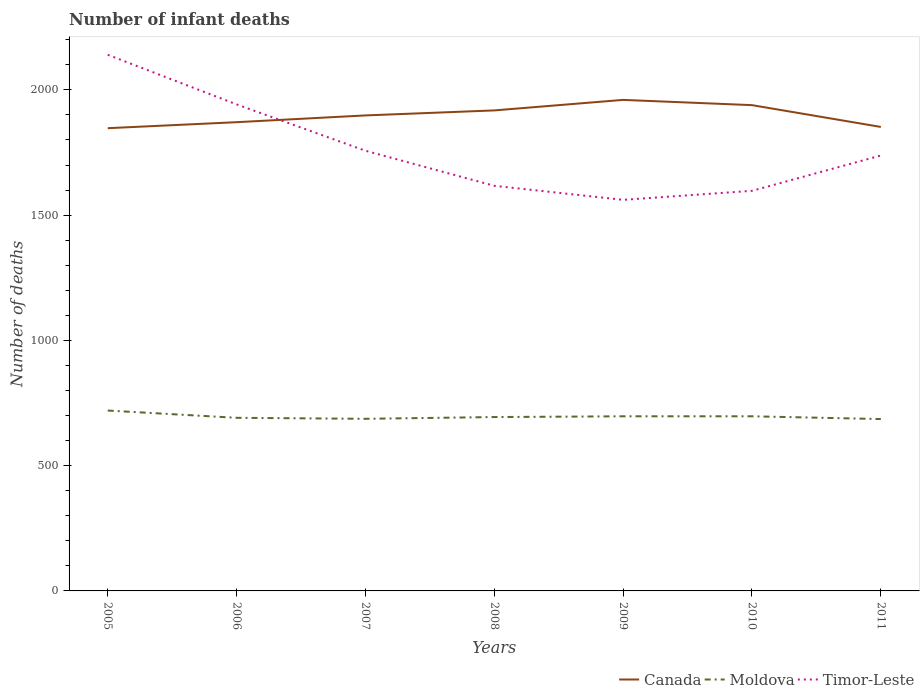Does the line corresponding to Canada intersect with the line corresponding to Moldova?
Provide a succinct answer. No. Across all years, what is the maximum number of infant deaths in Moldova?
Ensure brevity in your answer.  686. In which year was the number of infant deaths in Timor-Leste maximum?
Provide a succinct answer. 2009. What is the total number of infant deaths in Canada in the graph?
Offer a terse response. 87. What is the difference between the highest and the lowest number of infant deaths in Moldova?
Make the answer very short. 3. Is the number of infant deaths in Canada strictly greater than the number of infant deaths in Timor-Leste over the years?
Keep it short and to the point. No. How many lines are there?
Provide a succinct answer. 3. How many years are there in the graph?
Offer a very short reply. 7. Does the graph contain any zero values?
Provide a succinct answer. No. Does the graph contain grids?
Your answer should be very brief. No. What is the title of the graph?
Ensure brevity in your answer.  Number of infant deaths. Does "Senegal" appear as one of the legend labels in the graph?
Your response must be concise. No. What is the label or title of the X-axis?
Make the answer very short. Years. What is the label or title of the Y-axis?
Offer a very short reply. Number of deaths. What is the Number of deaths in Canada in 2005?
Provide a short and direct response. 1847. What is the Number of deaths of Moldova in 2005?
Ensure brevity in your answer.  720. What is the Number of deaths of Timor-Leste in 2005?
Keep it short and to the point. 2140. What is the Number of deaths of Canada in 2006?
Your answer should be very brief. 1871. What is the Number of deaths in Moldova in 2006?
Provide a short and direct response. 691. What is the Number of deaths in Timor-Leste in 2006?
Give a very brief answer. 1942. What is the Number of deaths in Canada in 2007?
Keep it short and to the point. 1898. What is the Number of deaths of Moldova in 2007?
Make the answer very short. 687. What is the Number of deaths of Timor-Leste in 2007?
Ensure brevity in your answer.  1757. What is the Number of deaths in Canada in 2008?
Ensure brevity in your answer.  1918. What is the Number of deaths in Moldova in 2008?
Provide a short and direct response. 694. What is the Number of deaths of Timor-Leste in 2008?
Offer a very short reply. 1617. What is the Number of deaths in Canada in 2009?
Keep it short and to the point. 1960. What is the Number of deaths in Moldova in 2009?
Your response must be concise. 697. What is the Number of deaths in Timor-Leste in 2009?
Give a very brief answer. 1561. What is the Number of deaths of Canada in 2010?
Make the answer very short. 1939. What is the Number of deaths in Moldova in 2010?
Make the answer very short. 697. What is the Number of deaths in Timor-Leste in 2010?
Keep it short and to the point. 1597. What is the Number of deaths in Canada in 2011?
Your answer should be very brief. 1852. What is the Number of deaths in Moldova in 2011?
Provide a short and direct response. 686. What is the Number of deaths of Timor-Leste in 2011?
Give a very brief answer. 1738. Across all years, what is the maximum Number of deaths of Canada?
Provide a succinct answer. 1960. Across all years, what is the maximum Number of deaths of Moldova?
Your response must be concise. 720. Across all years, what is the maximum Number of deaths in Timor-Leste?
Offer a terse response. 2140. Across all years, what is the minimum Number of deaths of Canada?
Your response must be concise. 1847. Across all years, what is the minimum Number of deaths in Moldova?
Keep it short and to the point. 686. Across all years, what is the minimum Number of deaths of Timor-Leste?
Offer a very short reply. 1561. What is the total Number of deaths in Canada in the graph?
Provide a succinct answer. 1.33e+04. What is the total Number of deaths of Moldova in the graph?
Give a very brief answer. 4872. What is the total Number of deaths in Timor-Leste in the graph?
Provide a succinct answer. 1.24e+04. What is the difference between the Number of deaths of Canada in 2005 and that in 2006?
Your answer should be very brief. -24. What is the difference between the Number of deaths in Moldova in 2005 and that in 2006?
Your response must be concise. 29. What is the difference between the Number of deaths in Timor-Leste in 2005 and that in 2006?
Offer a very short reply. 198. What is the difference between the Number of deaths of Canada in 2005 and that in 2007?
Offer a terse response. -51. What is the difference between the Number of deaths in Moldova in 2005 and that in 2007?
Make the answer very short. 33. What is the difference between the Number of deaths of Timor-Leste in 2005 and that in 2007?
Your response must be concise. 383. What is the difference between the Number of deaths of Canada in 2005 and that in 2008?
Keep it short and to the point. -71. What is the difference between the Number of deaths of Timor-Leste in 2005 and that in 2008?
Ensure brevity in your answer.  523. What is the difference between the Number of deaths in Canada in 2005 and that in 2009?
Provide a succinct answer. -113. What is the difference between the Number of deaths of Moldova in 2005 and that in 2009?
Offer a very short reply. 23. What is the difference between the Number of deaths in Timor-Leste in 2005 and that in 2009?
Keep it short and to the point. 579. What is the difference between the Number of deaths of Canada in 2005 and that in 2010?
Offer a terse response. -92. What is the difference between the Number of deaths of Moldova in 2005 and that in 2010?
Your answer should be very brief. 23. What is the difference between the Number of deaths of Timor-Leste in 2005 and that in 2010?
Ensure brevity in your answer.  543. What is the difference between the Number of deaths in Canada in 2005 and that in 2011?
Make the answer very short. -5. What is the difference between the Number of deaths of Timor-Leste in 2005 and that in 2011?
Offer a very short reply. 402. What is the difference between the Number of deaths of Moldova in 2006 and that in 2007?
Your answer should be very brief. 4. What is the difference between the Number of deaths in Timor-Leste in 2006 and that in 2007?
Give a very brief answer. 185. What is the difference between the Number of deaths of Canada in 2006 and that in 2008?
Offer a very short reply. -47. What is the difference between the Number of deaths of Timor-Leste in 2006 and that in 2008?
Give a very brief answer. 325. What is the difference between the Number of deaths in Canada in 2006 and that in 2009?
Your response must be concise. -89. What is the difference between the Number of deaths of Moldova in 2006 and that in 2009?
Your answer should be compact. -6. What is the difference between the Number of deaths of Timor-Leste in 2006 and that in 2009?
Your answer should be compact. 381. What is the difference between the Number of deaths of Canada in 2006 and that in 2010?
Make the answer very short. -68. What is the difference between the Number of deaths in Timor-Leste in 2006 and that in 2010?
Give a very brief answer. 345. What is the difference between the Number of deaths in Moldova in 2006 and that in 2011?
Make the answer very short. 5. What is the difference between the Number of deaths of Timor-Leste in 2006 and that in 2011?
Make the answer very short. 204. What is the difference between the Number of deaths in Moldova in 2007 and that in 2008?
Provide a succinct answer. -7. What is the difference between the Number of deaths of Timor-Leste in 2007 and that in 2008?
Ensure brevity in your answer.  140. What is the difference between the Number of deaths of Canada in 2007 and that in 2009?
Offer a terse response. -62. What is the difference between the Number of deaths in Timor-Leste in 2007 and that in 2009?
Your response must be concise. 196. What is the difference between the Number of deaths of Canada in 2007 and that in 2010?
Offer a terse response. -41. What is the difference between the Number of deaths of Moldova in 2007 and that in 2010?
Keep it short and to the point. -10. What is the difference between the Number of deaths in Timor-Leste in 2007 and that in 2010?
Your response must be concise. 160. What is the difference between the Number of deaths in Canada in 2007 and that in 2011?
Your response must be concise. 46. What is the difference between the Number of deaths of Moldova in 2007 and that in 2011?
Keep it short and to the point. 1. What is the difference between the Number of deaths of Canada in 2008 and that in 2009?
Your answer should be very brief. -42. What is the difference between the Number of deaths of Moldova in 2008 and that in 2009?
Offer a terse response. -3. What is the difference between the Number of deaths of Canada in 2008 and that in 2010?
Provide a short and direct response. -21. What is the difference between the Number of deaths of Moldova in 2008 and that in 2010?
Provide a short and direct response. -3. What is the difference between the Number of deaths in Canada in 2008 and that in 2011?
Make the answer very short. 66. What is the difference between the Number of deaths of Timor-Leste in 2008 and that in 2011?
Ensure brevity in your answer.  -121. What is the difference between the Number of deaths in Moldova in 2009 and that in 2010?
Give a very brief answer. 0. What is the difference between the Number of deaths in Timor-Leste in 2009 and that in 2010?
Keep it short and to the point. -36. What is the difference between the Number of deaths in Canada in 2009 and that in 2011?
Offer a terse response. 108. What is the difference between the Number of deaths of Moldova in 2009 and that in 2011?
Provide a succinct answer. 11. What is the difference between the Number of deaths of Timor-Leste in 2009 and that in 2011?
Provide a short and direct response. -177. What is the difference between the Number of deaths in Moldova in 2010 and that in 2011?
Your answer should be compact. 11. What is the difference between the Number of deaths in Timor-Leste in 2010 and that in 2011?
Ensure brevity in your answer.  -141. What is the difference between the Number of deaths of Canada in 2005 and the Number of deaths of Moldova in 2006?
Provide a succinct answer. 1156. What is the difference between the Number of deaths of Canada in 2005 and the Number of deaths of Timor-Leste in 2006?
Offer a terse response. -95. What is the difference between the Number of deaths in Moldova in 2005 and the Number of deaths in Timor-Leste in 2006?
Your response must be concise. -1222. What is the difference between the Number of deaths in Canada in 2005 and the Number of deaths in Moldova in 2007?
Make the answer very short. 1160. What is the difference between the Number of deaths in Canada in 2005 and the Number of deaths in Timor-Leste in 2007?
Your response must be concise. 90. What is the difference between the Number of deaths in Moldova in 2005 and the Number of deaths in Timor-Leste in 2007?
Ensure brevity in your answer.  -1037. What is the difference between the Number of deaths of Canada in 2005 and the Number of deaths of Moldova in 2008?
Provide a succinct answer. 1153. What is the difference between the Number of deaths of Canada in 2005 and the Number of deaths of Timor-Leste in 2008?
Provide a short and direct response. 230. What is the difference between the Number of deaths in Moldova in 2005 and the Number of deaths in Timor-Leste in 2008?
Provide a short and direct response. -897. What is the difference between the Number of deaths in Canada in 2005 and the Number of deaths in Moldova in 2009?
Your answer should be compact. 1150. What is the difference between the Number of deaths in Canada in 2005 and the Number of deaths in Timor-Leste in 2009?
Make the answer very short. 286. What is the difference between the Number of deaths in Moldova in 2005 and the Number of deaths in Timor-Leste in 2009?
Your response must be concise. -841. What is the difference between the Number of deaths of Canada in 2005 and the Number of deaths of Moldova in 2010?
Make the answer very short. 1150. What is the difference between the Number of deaths in Canada in 2005 and the Number of deaths in Timor-Leste in 2010?
Provide a succinct answer. 250. What is the difference between the Number of deaths in Moldova in 2005 and the Number of deaths in Timor-Leste in 2010?
Provide a short and direct response. -877. What is the difference between the Number of deaths of Canada in 2005 and the Number of deaths of Moldova in 2011?
Provide a short and direct response. 1161. What is the difference between the Number of deaths in Canada in 2005 and the Number of deaths in Timor-Leste in 2011?
Offer a terse response. 109. What is the difference between the Number of deaths in Moldova in 2005 and the Number of deaths in Timor-Leste in 2011?
Offer a terse response. -1018. What is the difference between the Number of deaths in Canada in 2006 and the Number of deaths in Moldova in 2007?
Keep it short and to the point. 1184. What is the difference between the Number of deaths in Canada in 2006 and the Number of deaths in Timor-Leste in 2007?
Provide a succinct answer. 114. What is the difference between the Number of deaths of Moldova in 2006 and the Number of deaths of Timor-Leste in 2007?
Provide a succinct answer. -1066. What is the difference between the Number of deaths of Canada in 2006 and the Number of deaths of Moldova in 2008?
Ensure brevity in your answer.  1177. What is the difference between the Number of deaths of Canada in 2006 and the Number of deaths of Timor-Leste in 2008?
Your answer should be very brief. 254. What is the difference between the Number of deaths in Moldova in 2006 and the Number of deaths in Timor-Leste in 2008?
Make the answer very short. -926. What is the difference between the Number of deaths in Canada in 2006 and the Number of deaths in Moldova in 2009?
Keep it short and to the point. 1174. What is the difference between the Number of deaths in Canada in 2006 and the Number of deaths in Timor-Leste in 2009?
Your answer should be very brief. 310. What is the difference between the Number of deaths in Moldova in 2006 and the Number of deaths in Timor-Leste in 2009?
Your answer should be compact. -870. What is the difference between the Number of deaths of Canada in 2006 and the Number of deaths of Moldova in 2010?
Offer a terse response. 1174. What is the difference between the Number of deaths in Canada in 2006 and the Number of deaths in Timor-Leste in 2010?
Your response must be concise. 274. What is the difference between the Number of deaths of Moldova in 2006 and the Number of deaths of Timor-Leste in 2010?
Offer a very short reply. -906. What is the difference between the Number of deaths of Canada in 2006 and the Number of deaths of Moldova in 2011?
Provide a short and direct response. 1185. What is the difference between the Number of deaths in Canada in 2006 and the Number of deaths in Timor-Leste in 2011?
Provide a short and direct response. 133. What is the difference between the Number of deaths of Moldova in 2006 and the Number of deaths of Timor-Leste in 2011?
Your response must be concise. -1047. What is the difference between the Number of deaths of Canada in 2007 and the Number of deaths of Moldova in 2008?
Keep it short and to the point. 1204. What is the difference between the Number of deaths in Canada in 2007 and the Number of deaths in Timor-Leste in 2008?
Provide a succinct answer. 281. What is the difference between the Number of deaths in Moldova in 2007 and the Number of deaths in Timor-Leste in 2008?
Make the answer very short. -930. What is the difference between the Number of deaths of Canada in 2007 and the Number of deaths of Moldova in 2009?
Your answer should be compact. 1201. What is the difference between the Number of deaths in Canada in 2007 and the Number of deaths in Timor-Leste in 2009?
Make the answer very short. 337. What is the difference between the Number of deaths in Moldova in 2007 and the Number of deaths in Timor-Leste in 2009?
Ensure brevity in your answer.  -874. What is the difference between the Number of deaths in Canada in 2007 and the Number of deaths in Moldova in 2010?
Give a very brief answer. 1201. What is the difference between the Number of deaths of Canada in 2007 and the Number of deaths of Timor-Leste in 2010?
Offer a terse response. 301. What is the difference between the Number of deaths of Moldova in 2007 and the Number of deaths of Timor-Leste in 2010?
Keep it short and to the point. -910. What is the difference between the Number of deaths in Canada in 2007 and the Number of deaths in Moldova in 2011?
Ensure brevity in your answer.  1212. What is the difference between the Number of deaths of Canada in 2007 and the Number of deaths of Timor-Leste in 2011?
Your answer should be very brief. 160. What is the difference between the Number of deaths in Moldova in 2007 and the Number of deaths in Timor-Leste in 2011?
Your response must be concise. -1051. What is the difference between the Number of deaths in Canada in 2008 and the Number of deaths in Moldova in 2009?
Offer a very short reply. 1221. What is the difference between the Number of deaths of Canada in 2008 and the Number of deaths of Timor-Leste in 2009?
Provide a short and direct response. 357. What is the difference between the Number of deaths in Moldova in 2008 and the Number of deaths in Timor-Leste in 2009?
Make the answer very short. -867. What is the difference between the Number of deaths in Canada in 2008 and the Number of deaths in Moldova in 2010?
Give a very brief answer. 1221. What is the difference between the Number of deaths of Canada in 2008 and the Number of deaths of Timor-Leste in 2010?
Give a very brief answer. 321. What is the difference between the Number of deaths of Moldova in 2008 and the Number of deaths of Timor-Leste in 2010?
Ensure brevity in your answer.  -903. What is the difference between the Number of deaths of Canada in 2008 and the Number of deaths of Moldova in 2011?
Keep it short and to the point. 1232. What is the difference between the Number of deaths of Canada in 2008 and the Number of deaths of Timor-Leste in 2011?
Your answer should be very brief. 180. What is the difference between the Number of deaths in Moldova in 2008 and the Number of deaths in Timor-Leste in 2011?
Give a very brief answer. -1044. What is the difference between the Number of deaths of Canada in 2009 and the Number of deaths of Moldova in 2010?
Offer a terse response. 1263. What is the difference between the Number of deaths of Canada in 2009 and the Number of deaths of Timor-Leste in 2010?
Give a very brief answer. 363. What is the difference between the Number of deaths in Moldova in 2009 and the Number of deaths in Timor-Leste in 2010?
Give a very brief answer. -900. What is the difference between the Number of deaths in Canada in 2009 and the Number of deaths in Moldova in 2011?
Keep it short and to the point. 1274. What is the difference between the Number of deaths in Canada in 2009 and the Number of deaths in Timor-Leste in 2011?
Your response must be concise. 222. What is the difference between the Number of deaths of Moldova in 2009 and the Number of deaths of Timor-Leste in 2011?
Give a very brief answer. -1041. What is the difference between the Number of deaths in Canada in 2010 and the Number of deaths in Moldova in 2011?
Make the answer very short. 1253. What is the difference between the Number of deaths of Canada in 2010 and the Number of deaths of Timor-Leste in 2011?
Ensure brevity in your answer.  201. What is the difference between the Number of deaths of Moldova in 2010 and the Number of deaths of Timor-Leste in 2011?
Your answer should be very brief. -1041. What is the average Number of deaths in Canada per year?
Give a very brief answer. 1897.86. What is the average Number of deaths of Moldova per year?
Provide a succinct answer. 696. What is the average Number of deaths in Timor-Leste per year?
Keep it short and to the point. 1764.57. In the year 2005, what is the difference between the Number of deaths of Canada and Number of deaths of Moldova?
Provide a succinct answer. 1127. In the year 2005, what is the difference between the Number of deaths in Canada and Number of deaths in Timor-Leste?
Offer a very short reply. -293. In the year 2005, what is the difference between the Number of deaths in Moldova and Number of deaths in Timor-Leste?
Offer a terse response. -1420. In the year 2006, what is the difference between the Number of deaths of Canada and Number of deaths of Moldova?
Make the answer very short. 1180. In the year 2006, what is the difference between the Number of deaths of Canada and Number of deaths of Timor-Leste?
Make the answer very short. -71. In the year 2006, what is the difference between the Number of deaths of Moldova and Number of deaths of Timor-Leste?
Give a very brief answer. -1251. In the year 2007, what is the difference between the Number of deaths in Canada and Number of deaths in Moldova?
Give a very brief answer. 1211. In the year 2007, what is the difference between the Number of deaths of Canada and Number of deaths of Timor-Leste?
Offer a terse response. 141. In the year 2007, what is the difference between the Number of deaths of Moldova and Number of deaths of Timor-Leste?
Your answer should be compact. -1070. In the year 2008, what is the difference between the Number of deaths in Canada and Number of deaths in Moldova?
Your response must be concise. 1224. In the year 2008, what is the difference between the Number of deaths of Canada and Number of deaths of Timor-Leste?
Your response must be concise. 301. In the year 2008, what is the difference between the Number of deaths in Moldova and Number of deaths in Timor-Leste?
Your answer should be very brief. -923. In the year 2009, what is the difference between the Number of deaths in Canada and Number of deaths in Moldova?
Offer a very short reply. 1263. In the year 2009, what is the difference between the Number of deaths in Canada and Number of deaths in Timor-Leste?
Offer a terse response. 399. In the year 2009, what is the difference between the Number of deaths in Moldova and Number of deaths in Timor-Leste?
Make the answer very short. -864. In the year 2010, what is the difference between the Number of deaths of Canada and Number of deaths of Moldova?
Make the answer very short. 1242. In the year 2010, what is the difference between the Number of deaths of Canada and Number of deaths of Timor-Leste?
Your response must be concise. 342. In the year 2010, what is the difference between the Number of deaths in Moldova and Number of deaths in Timor-Leste?
Your response must be concise. -900. In the year 2011, what is the difference between the Number of deaths of Canada and Number of deaths of Moldova?
Keep it short and to the point. 1166. In the year 2011, what is the difference between the Number of deaths of Canada and Number of deaths of Timor-Leste?
Offer a very short reply. 114. In the year 2011, what is the difference between the Number of deaths of Moldova and Number of deaths of Timor-Leste?
Provide a succinct answer. -1052. What is the ratio of the Number of deaths of Canada in 2005 to that in 2006?
Your answer should be very brief. 0.99. What is the ratio of the Number of deaths of Moldova in 2005 to that in 2006?
Provide a succinct answer. 1.04. What is the ratio of the Number of deaths in Timor-Leste in 2005 to that in 2006?
Offer a terse response. 1.1. What is the ratio of the Number of deaths in Canada in 2005 to that in 2007?
Your response must be concise. 0.97. What is the ratio of the Number of deaths in Moldova in 2005 to that in 2007?
Offer a very short reply. 1.05. What is the ratio of the Number of deaths in Timor-Leste in 2005 to that in 2007?
Offer a terse response. 1.22. What is the ratio of the Number of deaths of Moldova in 2005 to that in 2008?
Provide a succinct answer. 1.04. What is the ratio of the Number of deaths of Timor-Leste in 2005 to that in 2008?
Your answer should be very brief. 1.32. What is the ratio of the Number of deaths of Canada in 2005 to that in 2009?
Give a very brief answer. 0.94. What is the ratio of the Number of deaths of Moldova in 2005 to that in 2009?
Your answer should be very brief. 1.03. What is the ratio of the Number of deaths of Timor-Leste in 2005 to that in 2009?
Make the answer very short. 1.37. What is the ratio of the Number of deaths in Canada in 2005 to that in 2010?
Ensure brevity in your answer.  0.95. What is the ratio of the Number of deaths in Moldova in 2005 to that in 2010?
Keep it short and to the point. 1.03. What is the ratio of the Number of deaths in Timor-Leste in 2005 to that in 2010?
Ensure brevity in your answer.  1.34. What is the ratio of the Number of deaths of Canada in 2005 to that in 2011?
Make the answer very short. 1. What is the ratio of the Number of deaths in Moldova in 2005 to that in 2011?
Your response must be concise. 1.05. What is the ratio of the Number of deaths of Timor-Leste in 2005 to that in 2011?
Give a very brief answer. 1.23. What is the ratio of the Number of deaths of Canada in 2006 to that in 2007?
Give a very brief answer. 0.99. What is the ratio of the Number of deaths of Timor-Leste in 2006 to that in 2007?
Make the answer very short. 1.11. What is the ratio of the Number of deaths of Canada in 2006 to that in 2008?
Provide a succinct answer. 0.98. What is the ratio of the Number of deaths of Timor-Leste in 2006 to that in 2008?
Provide a succinct answer. 1.2. What is the ratio of the Number of deaths of Canada in 2006 to that in 2009?
Offer a very short reply. 0.95. What is the ratio of the Number of deaths in Moldova in 2006 to that in 2009?
Your answer should be compact. 0.99. What is the ratio of the Number of deaths in Timor-Leste in 2006 to that in 2009?
Your response must be concise. 1.24. What is the ratio of the Number of deaths of Canada in 2006 to that in 2010?
Make the answer very short. 0.96. What is the ratio of the Number of deaths of Moldova in 2006 to that in 2010?
Offer a terse response. 0.99. What is the ratio of the Number of deaths of Timor-Leste in 2006 to that in 2010?
Provide a short and direct response. 1.22. What is the ratio of the Number of deaths in Canada in 2006 to that in 2011?
Provide a short and direct response. 1.01. What is the ratio of the Number of deaths of Moldova in 2006 to that in 2011?
Your answer should be very brief. 1.01. What is the ratio of the Number of deaths of Timor-Leste in 2006 to that in 2011?
Offer a terse response. 1.12. What is the ratio of the Number of deaths in Canada in 2007 to that in 2008?
Keep it short and to the point. 0.99. What is the ratio of the Number of deaths in Timor-Leste in 2007 to that in 2008?
Your answer should be compact. 1.09. What is the ratio of the Number of deaths of Canada in 2007 to that in 2009?
Provide a succinct answer. 0.97. What is the ratio of the Number of deaths of Moldova in 2007 to that in 2009?
Keep it short and to the point. 0.99. What is the ratio of the Number of deaths of Timor-Leste in 2007 to that in 2009?
Provide a succinct answer. 1.13. What is the ratio of the Number of deaths in Canada in 2007 to that in 2010?
Your answer should be very brief. 0.98. What is the ratio of the Number of deaths of Moldova in 2007 to that in 2010?
Offer a terse response. 0.99. What is the ratio of the Number of deaths of Timor-Leste in 2007 to that in 2010?
Make the answer very short. 1.1. What is the ratio of the Number of deaths of Canada in 2007 to that in 2011?
Offer a very short reply. 1.02. What is the ratio of the Number of deaths of Timor-Leste in 2007 to that in 2011?
Offer a very short reply. 1.01. What is the ratio of the Number of deaths of Canada in 2008 to that in 2009?
Keep it short and to the point. 0.98. What is the ratio of the Number of deaths of Timor-Leste in 2008 to that in 2009?
Keep it short and to the point. 1.04. What is the ratio of the Number of deaths of Canada in 2008 to that in 2010?
Provide a succinct answer. 0.99. What is the ratio of the Number of deaths of Moldova in 2008 to that in 2010?
Your answer should be very brief. 1. What is the ratio of the Number of deaths in Timor-Leste in 2008 to that in 2010?
Keep it short and to the point. 1.01. What is the ratio of the Number of deaths of Canada in 2008 to that in 2011?
Offer a very short reply. 1.04. What is the ratio of the Number of deaths in Moldova in 2008 to that in 2011?
Your answer should be compact. 1.01. What is the ratio of the Number of deaths of Timor-Leste in 2008 to that in 2011?
Offer a terse response. 0.93. What is the ratio of the Number of deaths of Canada in 2009 to that in 2010?
Offer a terse response. 1.01. What is the ratio of the Number of deaths in Timor-Leste in 2009 to that in 2010?
Provide a succinct answer. 0.98. What is the ratio of the Number of deaths in Canada in 2009 to that in 2011?
Your response must be concise. 1.06. What is the ratio of the Number of deaths in Moldova in 2009 to that in 2011?
Provide a succinct answer. 1.02. What is the ratio of the Number of deaths of Timor-Leste in 2009 to that in 2011?
Your answer should be compact. 0.9. What is the ratio of the Number of deaths in Canada in 2010 to that in 2011?
Provide a succinct answer. 1.05. What is the ratio of the Number of deaths in Moldova in 2010 to that in 2011?
Provide a short and direct response. 1.02. What is the ratio of the Number of deaths of Timor-Leste in 2010 to that in 2011?
Your response must be concise. 0.92. What is the difference between the highest and the second highest Number of deaths of Canada?
Your answer should be very brief. 21. What is the difference between the highest and the second highest Number of deaths in Timor-Leste?
Keep it short and to the point. 198. What is the difference between the highest and the lowest Number of deaths of Canada?
Your answer should be compact. 113. What is the difference between the highest and the lowest Number of deaths in Timor-Leste?
Provide a succinct answer. 579. 